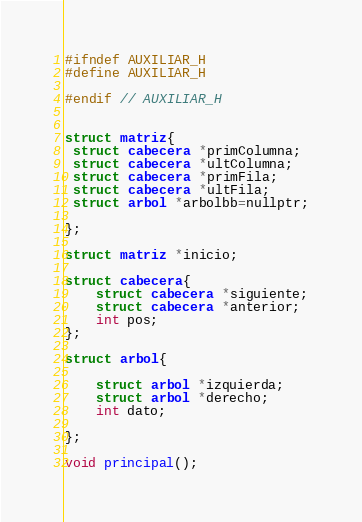<code> <loc_0><loc_0><loc_500><loc_500><_C_>#ifndef AUXILIAR_H
#define AUXILIAR_H

#endif // AUXILIAR_H


struct matriz{
 struct cabecera *primColumna;
 struct cabecera *ultColumna;
 struct cabecera *primFila;
 struct cabecera *ultFila;
 struct arbol *arbolbb=nullptr;

};

struct matriz *inicio;

struct cabecera{
    struct cabecera *siguiente;
    struct cabecera *anterior;
    int pos;
};

struct arbol{

    struct arbol *izquierda;
    struct arbol *derecho;
    int dato;

};

void principal();
</code> 